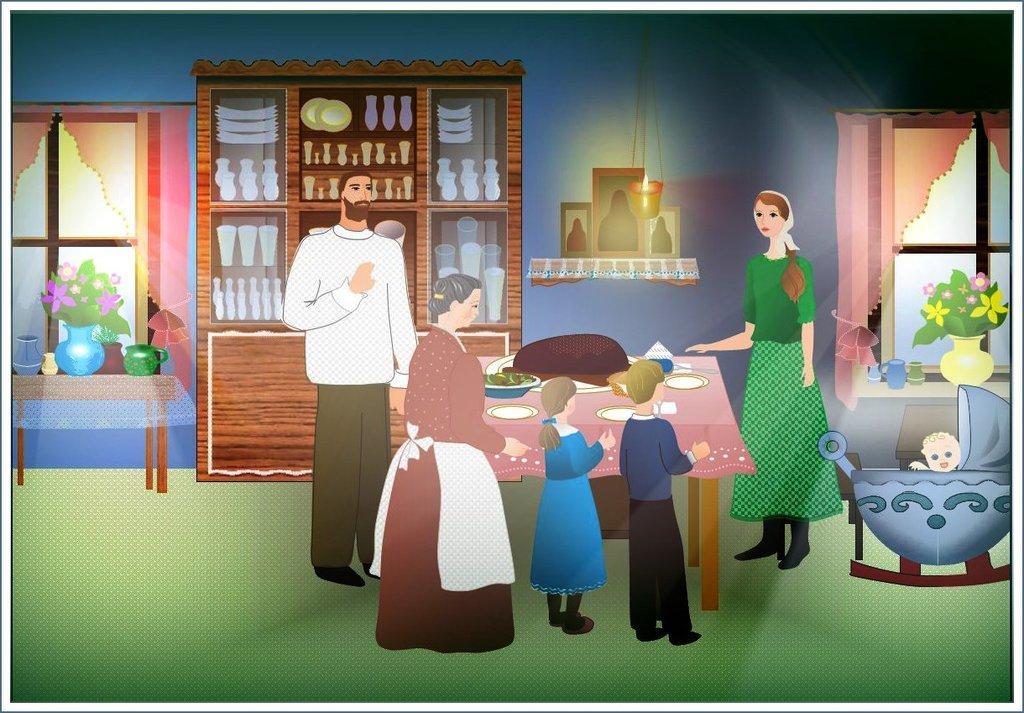Describe this image in one or two sentences. It is a cartoon image. In the image in the center we can see few people standing around table. On table,we can see plates,black color object and some food items. In the background we can see wall,window,curtains,shelf,plant pots,pots,candle,plates and few more objects. And on the right side we can see baby in the swing. 